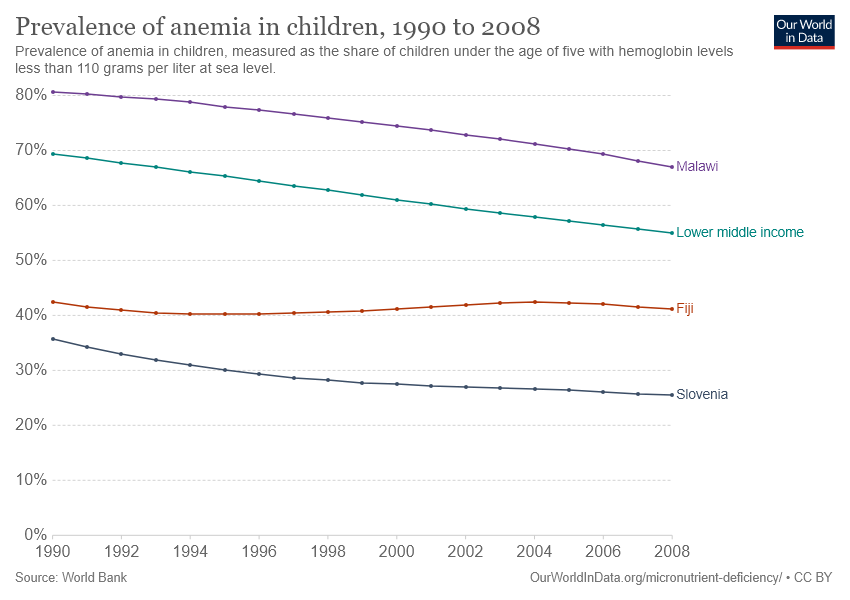Outline some significant characteristics in this image. The purple line on the graph represents Malawi. The prevalence of anemia in children in Malawi decreased from 1991 to 2005, with a difference of 0.1%. 